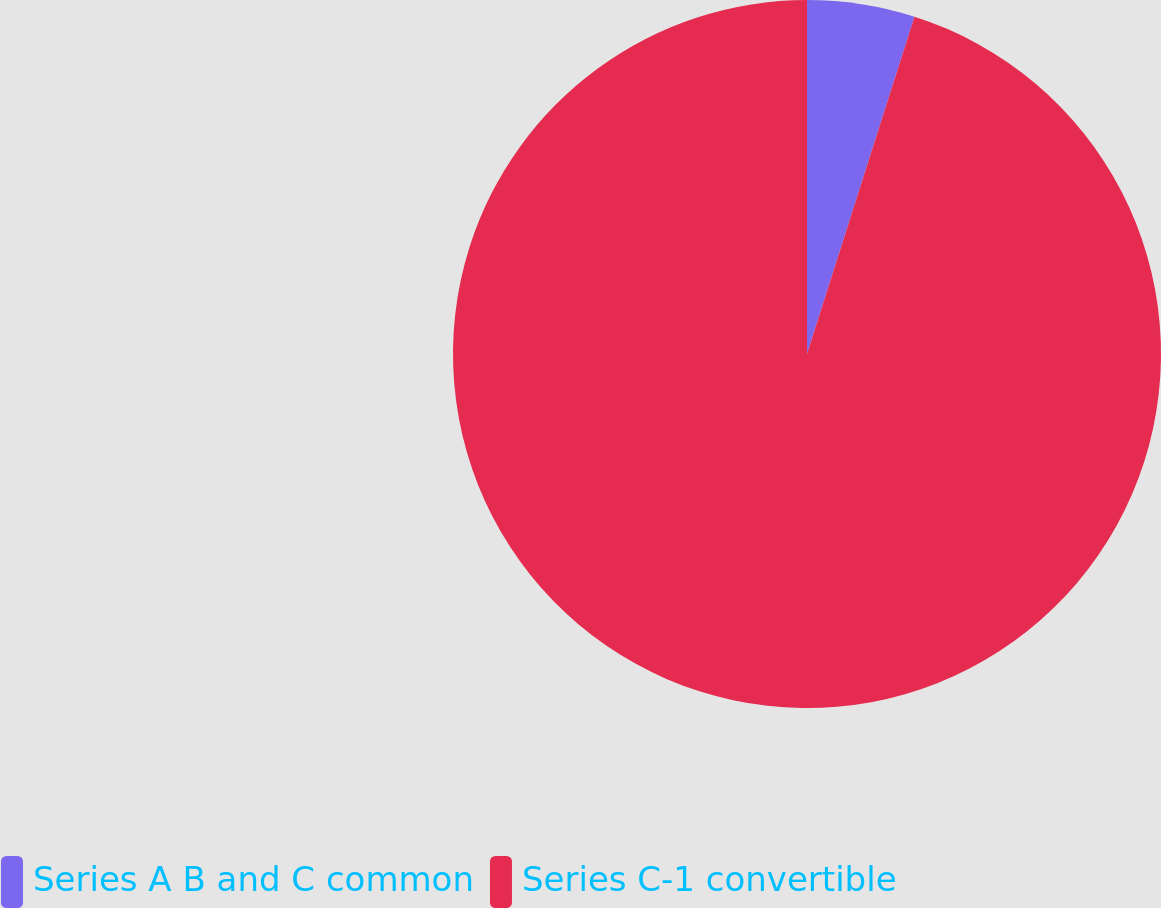<chart> <loc_0><loc_0><loc_500><loc_500><pie_chart><fcel>Series A B and C common<fcel>Series C-1 convertible<nl><fcel>4.91%<fcel>95.09%<nl></chart> 